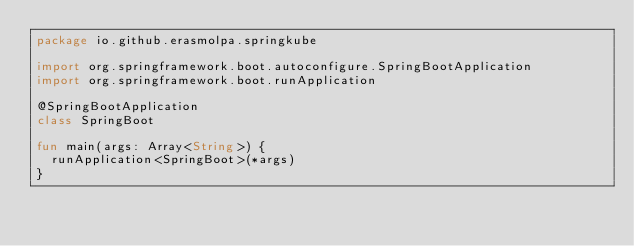Convert code to text. <code><loc_0><loc_0><loc_500><loc_500><_Kotlin_>package io.github.erasmolpa.springkube

import org.springframework.boot.autoconfigure.SpringBootApplication
import org.springframework.boot.runApplication

@SpringBootApplication
class SpringBoot

fun main(args: Array<String>) {
	runApplication<SpringBoot>(*args)
}
</code> 